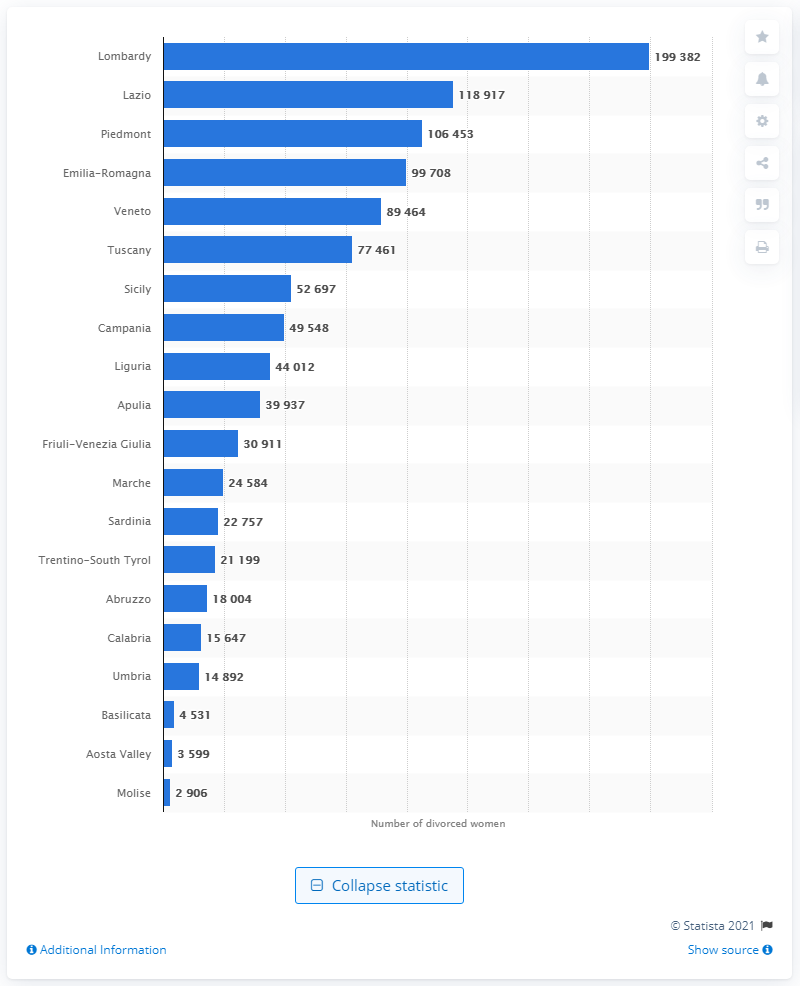Point out several critical features in this image. In January 2019, there were 118,917 divorced women living in the region of Lazio. In January 2019, there were 199,382 divorced women living in the region of Lombardy. 